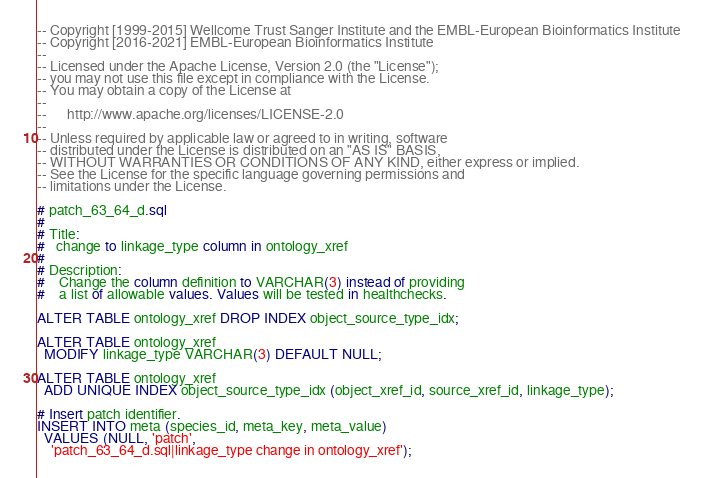Convert code to text. <code><loc_0><loc_0><loc_500><loc_500><_SQL_>-- Copyright [1999-2015] Wellcome Trust Sanger Institute and the EMBL-European Bioinformatics Institute
-- Copyright [2016-2021] EMBL-European Bioinformatics Institute
-- 
-- Licensed under the Apache License, Version 2.0 (the "License");
-- you may not use this file except in compliance with the License.
-- You may obtain a copy of the License at
-- 
--      http://www.apache.org/licenses/LICENSE-2.0
-- 
-- Unless required by applicable law or agreed to in writing, software
-- distributed under the License is distributed on an "AS IS" BASIS,
-- WITHOUT WARRANTIES OR CONDITIONS OF ANY KIND, either express or implied.
-- See the License for the specific language governing permissions and
-- limitations under the License.

# patch_63_64_d.sql
#
# Title:
#   change to linkage_type column in ontology_xref 
#
# Description:
#    Change the column definition to VARCHAR(3) instead of providing
#    a list of allowable values. Values will be tested in healthchecks.

ALTER TABLE ontology_xref DROP INDEX object_source_type_idx;

ALTER TABLE ontology_xref
  MODIFY linkage_type VARCHAR(3) DEFAULT NULL;

ALTER TABLE ontology_xref 
  ADD UNIQUE INDEX object_source_type_idx (object_xref_id, source_xref_id, linkage_type);

# Insert patch identifier.
INSERT INTO meta (species_id, meta_key, meta_value)
  VALUES (NULL, 'patch',
    'patch_63_64_d.sql|linkage_type change in ontology_xref');
</code> 